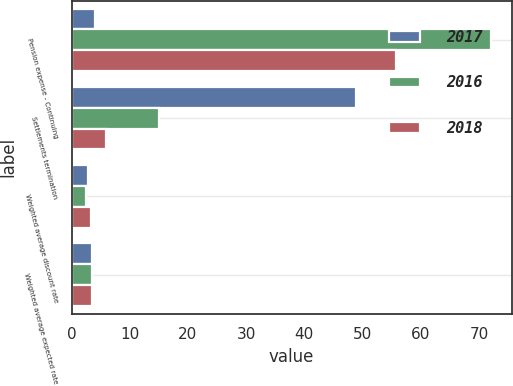Convert chart. <chart><loc_0><loc_0><loc_500><loc_500><stacked_bar_chart><ecel><fcel>Pension expense - Continuing<fcel>Settlements termination<fcel>Weighted average discount rate<fcel>Weighted average expected rate<nl><fcel>2017<fcel>4.1<fcel>48.9<fcel>2.9<fcel>3.5<nl><fcel>2016<fcel>72<fcel>15<fcel>2.5<fcel>3.5<nl><fcel>2018<fcel>55.8<fcel>6<fcel>3.4<fcel>3.5<nl></chart> 